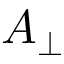Convert formula to latex. <formula><loc_0><loc_0><loc_500><loc_500>A _ { \perp }</formula> 